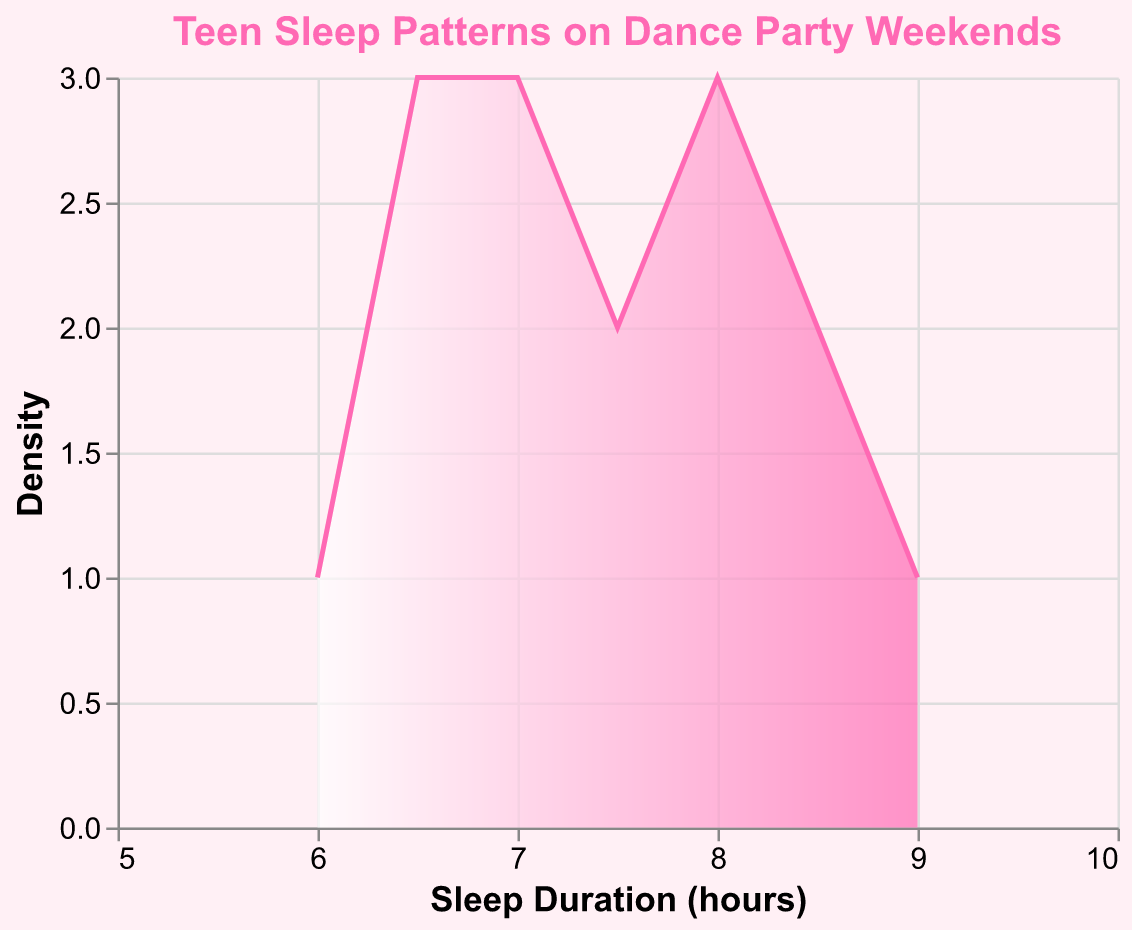What is the title of the figure? The title of the figure is located at the top center of the plot. It is usually in a larger font and summarizes the main topic of the visual. Here, it reads "Teen Sleep Patterns on Dance Party Weekends".
Answer: Teen Sleep Patterns on Dance Party Weekends What is the range of Sleep Duration shown on the x-axis? The x-axis represents the Sleep Duration in hours. It starts at 5 hours and ends at 10 hours, as indicated by the x-axis scale.
Answer: 5 to 10 hours How is the density represented in this plot? The density is shown on the y-axis and is calculated as the count of occurrences at each Sleep Duration value. This is indicated by the "Density" label on the y-axis and the use of the area mark.
Answer: By count of occurrences Which color gradient is used for the area fill? The area fill uses a color gradient that starts from white at the bottom and transitions to a pink color (#FF69B4) at the top, providing a visual cue for density.
Answer: White to pink What is the highest Sleep Duration recorded? The highest Sleep Duration data point can be identified directly from the x-axis. The maximum value is 9.0 hours.
Answer: 9.0 hours What is the most common Sleep Duration? To find the most common Sleep Duration, we look for the peak of the density curve. The highest point (density) is around the duration of 7.0 hours to 7.5 hours.
Answer: Around 7.0 to 7.5 hours What is the median Sleep Duration? The median Sleep Duration is found by ordering the data and picking the middle value. Counting samples and sorting them, we find that the median lies between the 7th and 8th values. Here, the median is approximately 7.5 hours.
Answer: 7.5 hours Compare the number of data points between Sleep Duration of 6.5 and 8.0 hours. To compare, we look at the height of the density curve for these values. The density at 6.5 hours is lower than at 8.0 hours, indicating fewer data points at 6.5 hours compared to 8.0 hours.
Answer: Fewer at 6.5 than at 8.0 What is the density of Sleep Duration at 7.0 hours? The density at 7.0 hours can be identified by looking at the y-axis value corresponding to the highest peak directly above 7.0 hours on the x-axis. This value is higher than any other point, suggesting it is the peak.
Answer: Highest density During what time interval do most teens tend to go to sleep? The TimeToSleep data can be inferred indirectly by analyzing the distribution pattern but here it's not directly represented on the plot. However, we know from the provided data values that most fall around 00:00 to 01:45 AM.
Answer: 00:00 to 01:45 AM 